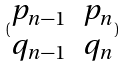Convert formula to latex. <formula><loc_0><loc_0><loc_500><loc_500>( \begin{matrix} p _ { n - 1 } & p _ { n } \\ q _ { n - 1 } & q _ { n } \end{matrix} )</formula> 